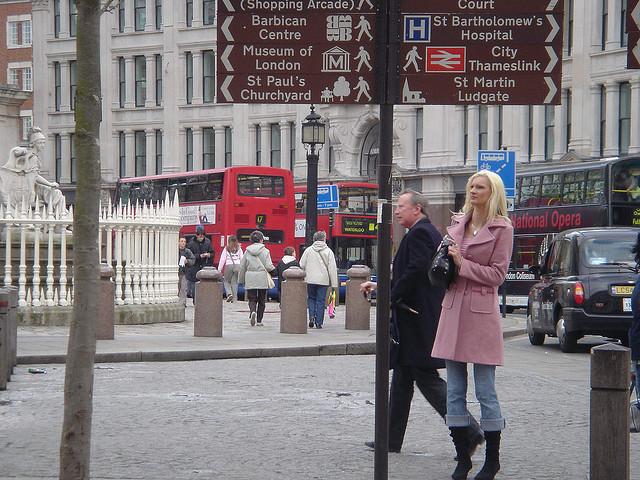Is the lady in the pink coat a brunette?
Write a very short answer. No. What vehicle is behind the fence?
Keep it brief. Bus. What does the red sign say?
Quick response, please. Opera. What is the girl holding?
Give a very brief answer. Purse. What color laces is on the girl's boots?
Give a very brief answer. Black. Does this look to be in the USA?
Answer briefly. No. Is there a restaurant with umbrellas?
Concise answer only. No. What gender is the person wearing the pink coat?
Be succinct. Female. Do the boots of the blonde woman have heels?
Write a very short answer. Yes. Are the signs in English?
Quick response, please. Yes. What is the woman waiting for?
Give a very brief answer. Bus. Is the woman in the photo lost?
Concise answer only. No. 